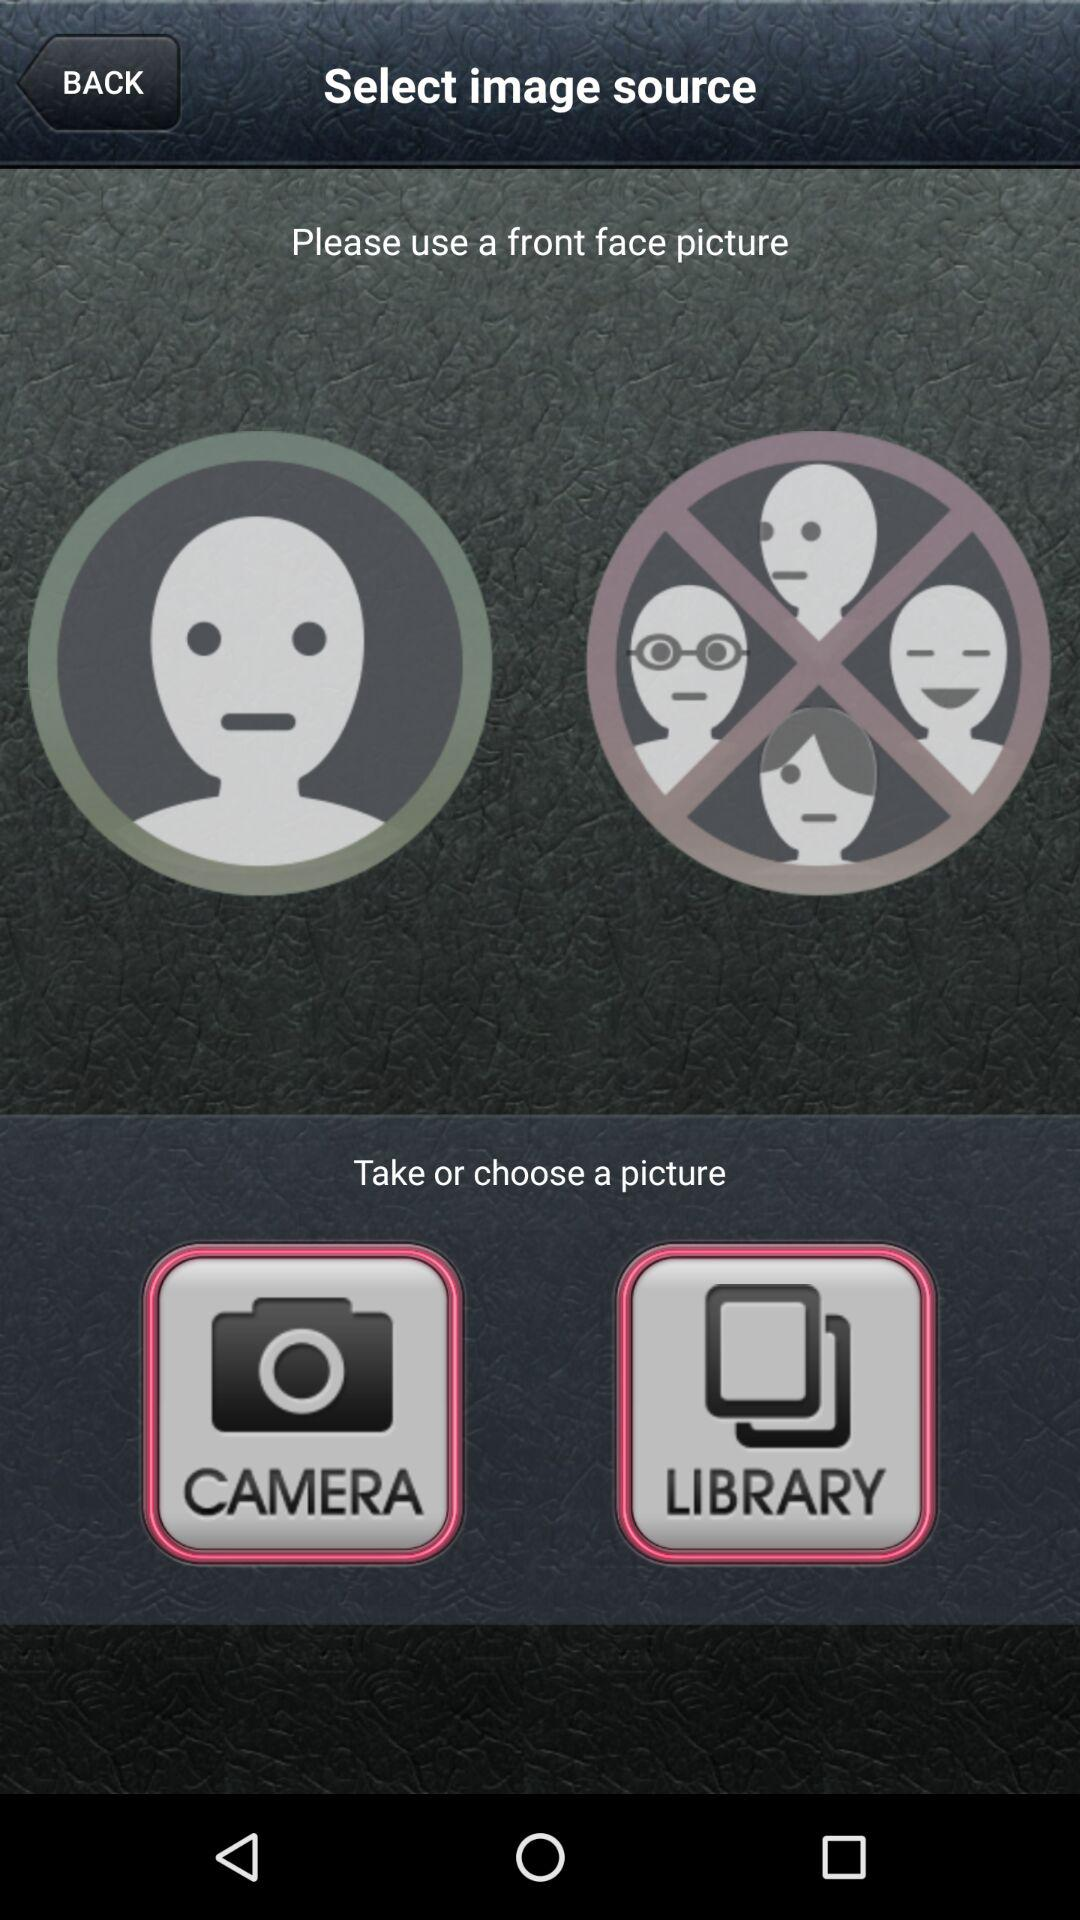What are the options for choosing pictures? The options for choosing pictures are "CAMERA" and "LIBRARY". 